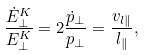<formula> <loc_0><loc_0><loc_500><loc_500>\frac { \dot { E } ^ { K } _ { \perp } } { E ^ { K } _ { \perp } } = 2 \frac { \dot { p } _ { \perp } } { p _ { \perp } } = \frac { v _ { l \| } } { l _ { \| } } ,</formula> 